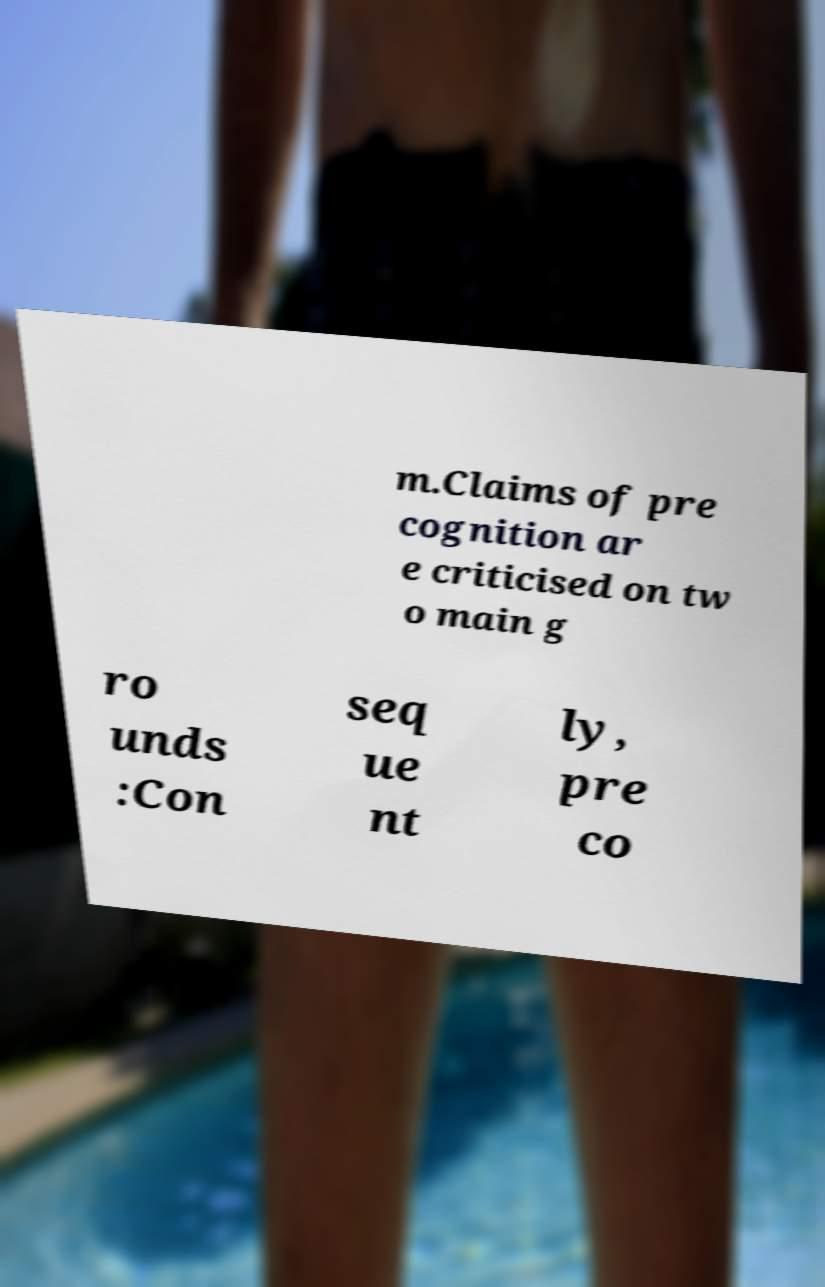What messages or text are displayed in this image? I need them in a readable, typed format. m.Claims of pre cognition ar e criticised on tw o main g ro unds :Con seq ue nt ly, pre co 